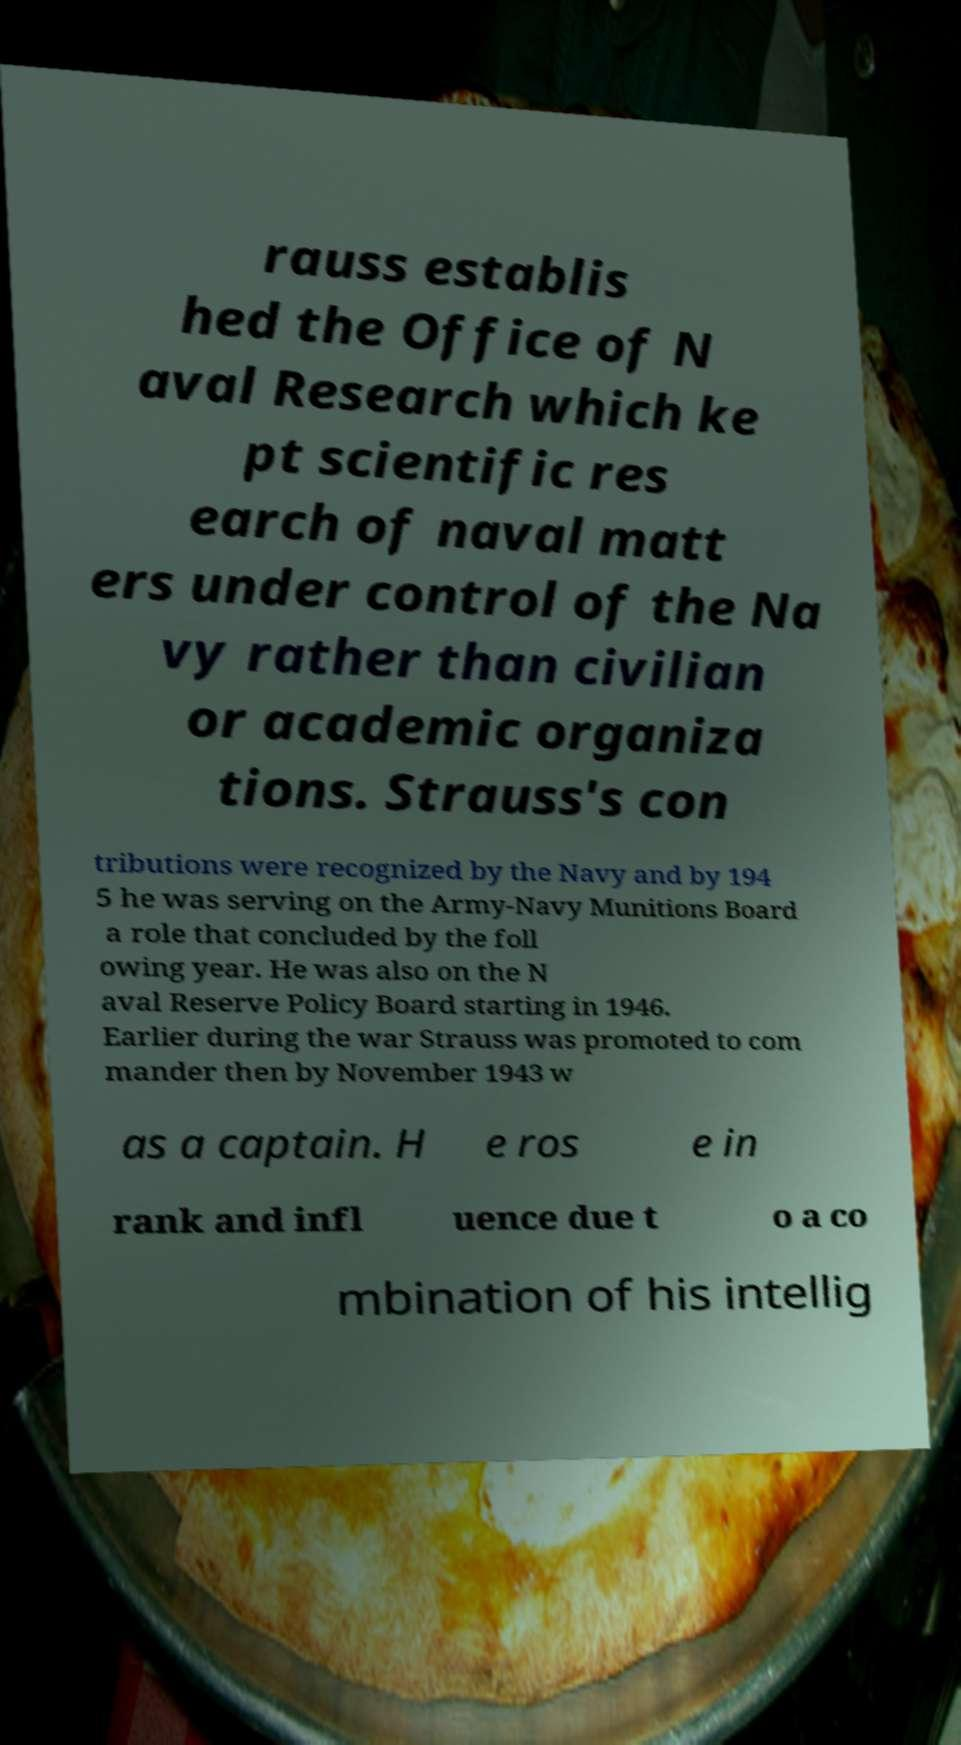There's text embedded in this image that I need extracted. Can you transcribe it verbatim? rauss establis hed the Office of N aval Research which ke pt scientific res earch of naval matt ers under control of the Na vy rather than civilian or academic organiza tions. Strauss's con tributions were recognized by the Navy and by 194 5 he was serving on the Army-Navy Munitions Board a role that concluded by the foll owing year. He was also on the N aval Reserve Policy Board starting in 1946. Earlier during the war Strauss was promoted to com mander then by November 1943 w as a captain. H e ros e in rank and infl uence due t o a co mbination of his intellig 